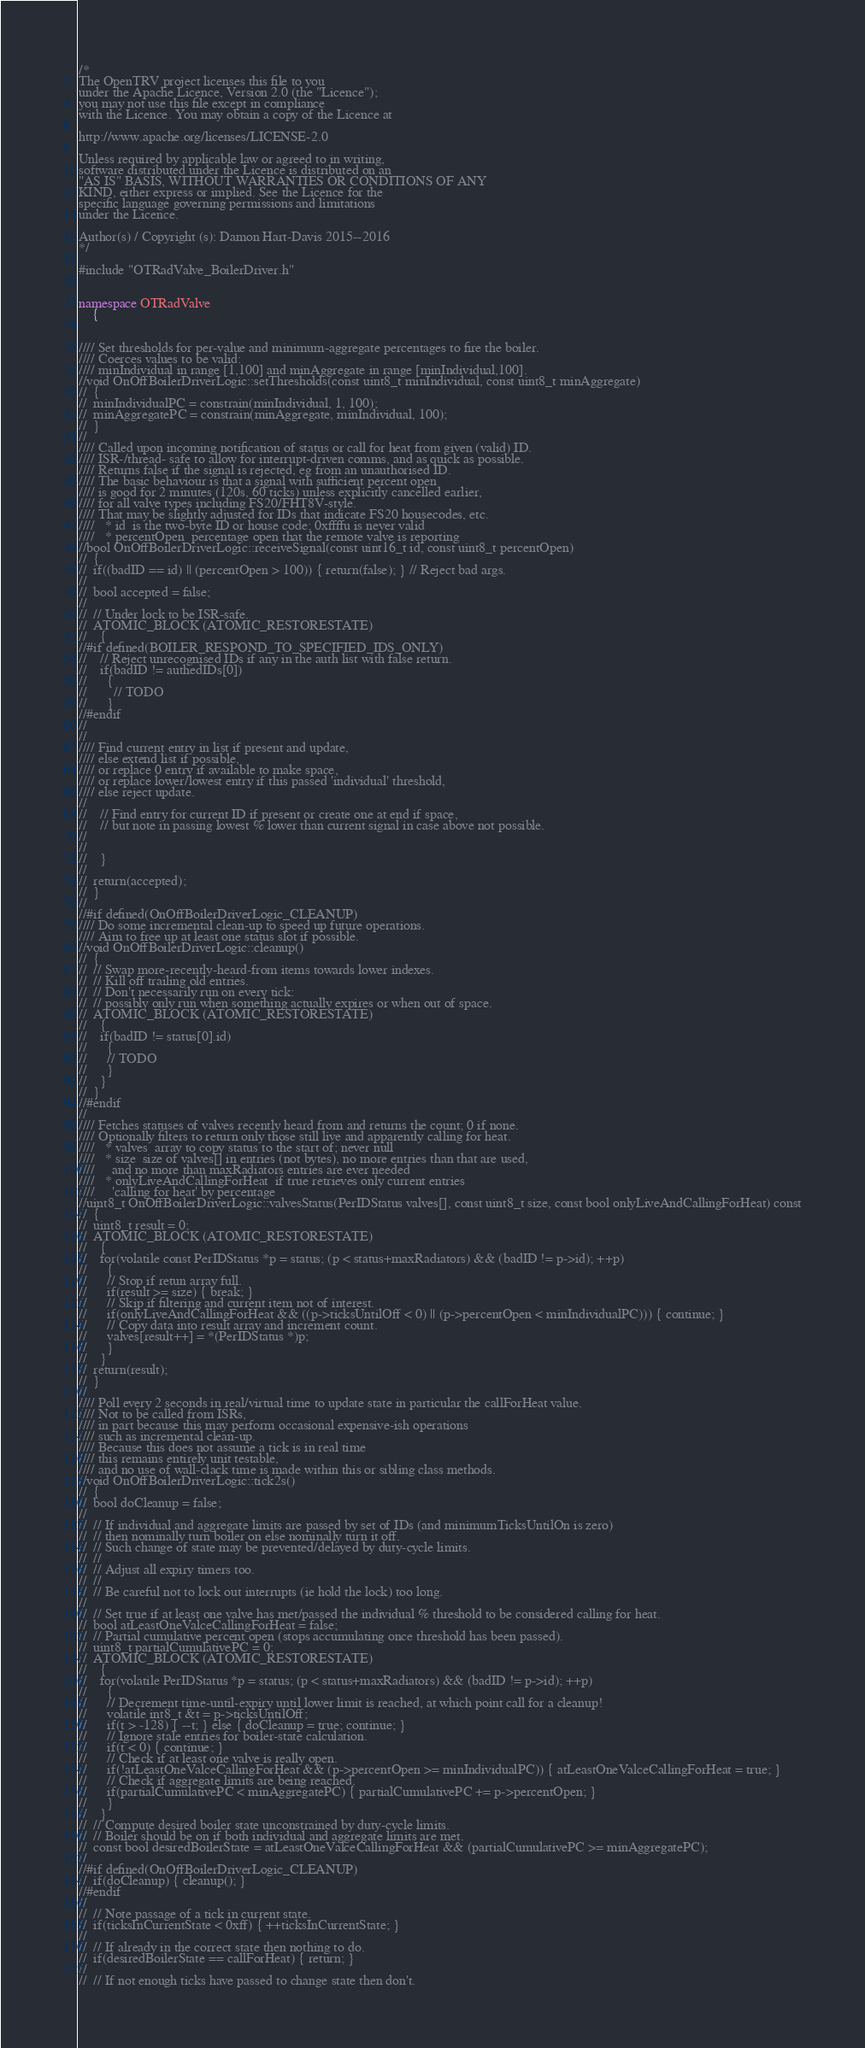<code> <loc_0><loc_0><loc_500><loc_500><_C++_>/*
The OpenTRV project licenses this file to you
under the Apache Licence, Version 2.0 (the "Licence");
you may not use this file except in compliance
with the Licence. You may obtain a copy of the Licence at

http://www.apache.org/licenses/LICENSE-2.0

Unless required by applicable law or agreed to in writing,
software distributed under the Licence is distributed on an
"AS IS" BASIS, WITHOUT WARRANTIES OR CONDITIONS OF ANY
KIND, either express or implied. See the Licence for the
specific language governing permissions and limitations
under the Licence.

Author(s) / Copyright (s): Damon Hart-Davis 2015--2016
*/

#include "OTRadValve_BoilerDriver.h"


namespace OTRadValve
    {


//// Set thresholds for per-value and minimum-aggregate percentages to fire the boiler.
//// Coerces values to be valid:
//// minIndividual in range [1,100] and minAggregate in range [minIndividual,100].
//void OnOffBoilerDriverLogic::setThresholds(const uint8_t minIndividual, const uint8_t minAggregate)
//  {
//  minIndividualPC = constrain(minIndividual, 1, 100);
//  minAggregatePC = constrain(minAggregate, minIndividual, 100);
//  }
//
//// Called upon incoming notification of status or call for heat from given (valid) ID.
//// ISR-/thread- safe to allow for interrupt-driven comms, and as quick as possible.
//// Returns false if the signal is rejected, eg from an unauthorised ID.
//// The basic behaviour is that a signal with sufficient percent open
//// is good for 2 minutes (120s, 60 ticks) unless explicitly cancelled earlier,
//// for all valve types including FS20/FHT8V-style.
//// That may be slightly adjusted for IDs that indicate FS20 housecodes, etc.
////   * id  is the two-byte ID or house code; 0xffffu is never valid
////   * percentOpen  percentage open that the remote valve is reporting
//bool OnOffBoilerDriverLogic::receiveSignal(const uint16_t id, const uint8_t percentOpen)
//  {
//  if((badID == id) || (percentOpen > 100)) { return(false); } // Reject bad args.
//
//  bool accepted = false;
//
//  // Under lock to be ISR-safe.
//  ATOMIC_BLOCK (ATOMIC_RESTORESTATE)
//    {
//#if defined(BOILER_RESPOND_TO_SPECIFIED_IDS_ONLY)
//    // Reject unrecognised IDs if any in the auth list with false return.
//    if(badID != authedIDs[0])
//      {
//        // TODO
//      }
//#endif
//
//
//// Find current entry in list if present and update,
//// else extend list if possible,
//// or replace 0 entry if available to make space,
//// or replace lower/lowest entry if this passed 'individual' threshold,
//// else reject update.
//
//    // Find entry for current ID if present or create one at end if space,
//    // but note in passing lowest % lower than current signal in case above not possible.
//
//
//    }
//
//  return(accepted);
//  }
//
//#if defined(OnOffBoilerDriverLogic_CLEANUP)
//// Do some incremental clean-up to speed up future operations.
//// Aim to free up at least one status slot if possible.
//void OnOffBoilerDriverLogic::cleanup()
//  {
//  // Swap more-recently-heard-from items towards lower indexes.
//  // Kill off trailing old entries.
//  // Don't necessarily run on every tick:
//  // possibly only run when something actually expires or when out of space.
//  ATOMIC_BLOCK (ATOMIC_RESTORESTATE)
//    {
//    if(badID != status[0].id)
//      {
//      // TODO
//      }
//    }
//  }
//#endif
//
//// Fetches statuses of valves recently heard from and returns the count; 0 if none.
//// Optionally filters to return only those still live and apparently calling for heat.
////   * valves  array to copy status to the start of; never null
////   * size  size of valves[] in entries (not bytes), no more entries than that are used,
////     and no more than maxRadiators entries are ever needed
////   * onlyLiveAndCallingForHeat  if true retrieves only current entries
////     'calling for heat' by percentage
//uint8_t OnOffBoilerDriverLogic::valvesStatus(PerIDStatus valves[], const uint8_t size, const bool onlyLiveAndCallingForHeat) const
//  {
//  uint8_t result = 0;
//  ATOMIC_BLOCK (ATOMIC_RESTORESTATE)
//    {
//    for(volatile const PerIDStatus *p = status; (p < status+maxRadiators) && (badID != p->id); ++p)
//      {
//      // Stop if retun array full.
//      if(result >= size) { break; }
//      // Skip if filtering and current item not of interest.
//      if(onlyLiveAndCallingForHeat && ((p->ticksUntilOff < 0) || (p->percentOpen < minIndividualPC))) { continue; }
//      // Copy data into result array and increment count.
//      valves[result++] = *(PerIDStatus *)p;
//      }
//    }
//  return(result);
//  }
//
//// Poll every 2 seconds in real/virtual time to update state in particular the callForHeat value.
//// Not to be called from ISRs,
//// in part because this may perform occasional expensive-ish operations
//// such as incremental clean-up.
//// Because this does not assume a tick is in real time
//// this remains entirely unit testable,
//// and no use of wall-clack time is made within this or sibling class methods.
//void OnOffBoilerDriverLogic::tick2s()
//  {
//  bool doCleanup = false;
//
//  // If individual and aggregate limits are passed by set of IDs (and minimumTicksUntilOn is zero)
//  // then nominally turn boiler on else nominally turn it off.
//  // Such change of state may be prevented/delayed by duty-cycle limits.
//  //
//  // Adjust all expiry timers too.
//  //
//  // Be careful not to lock out interrupts (ie hold the lock) too long.
//
//  // Set true if at least one valve has met/passed the individual % threshold to be considered calling for heat.
//  bool atLeastOneValceCallingForHeat = false;
//  // Partial cumulative percent open (stops accumulating once threshold has been passed).
//  uint8_t partialCumulativePC = 0;
//  ATOMIC_BLOCK (ATOMIC_RESTORESTATE)
//    {
//    for(volatile PerIDStatus *p = status; (p < status+maxRadiators) && (badID != p->id); ++p)
//      {
//      // Decrement time-until-expiry until lower limit is reached, at which point call for a cleanup!
//      volatile int8_t &t = p->ticksUntilOff;
//      if(t > -128) { --t; } else { doCleanup = true; continue; }
//      // Ignore stale entries for boiler-state calculation.
//      if(t < 0) { continue; }
//      // Check if at least one valve is really open.
//      if(!atLeastOneValceCallingForHeat && (p->percentOpen >= minIndividualPC)) { atLeastOneValceCallingForHeat = true; }
//      // Check if aggregate limits are being reached.
//      if(partialCumulativePC < minAggregatePC) { partialCumulativePC += p->percentOpen; }
//      }
//    }
//  // Compute desired boiler state unconstrained by duty-cycle limits.
//  // Boiler should be on if both individual and aggregate limits are met.
//  const bool desiredBoilerState = atLeastOneValceCallingForHeat && (partialCumulativePC >= minAggregatePC);
//
//#if defined(OnOffBoilerDriverLogic_CLEANUP)
//  if(doCleanup) { cleanup(); }
//#endif
//
//  // Note passage of a tick in current state.
//  if(ticksInCurrentState < 0xff) { ++ticksInCurrentState; }
//
//  // If already in the correct state then nothing to do.
//  if(desiredBoilerState == callForHeat) { return; }
//
//  // If not enough ticks have passed to change state then don't.</code> 